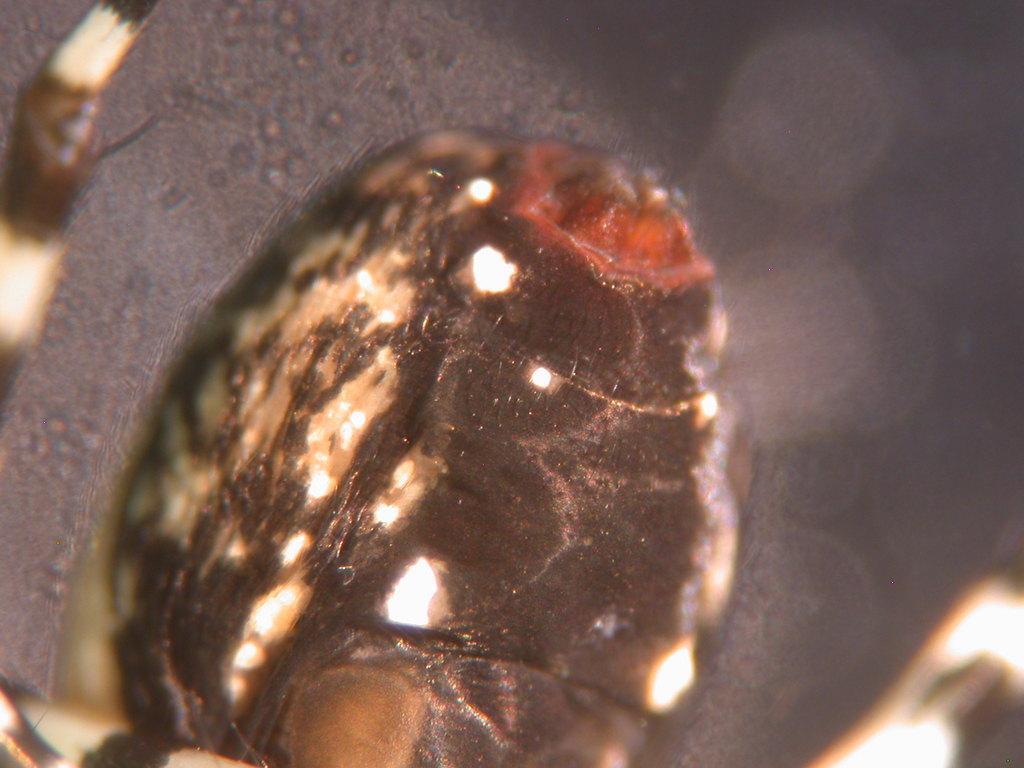What type of creature is present in the image? There is an insect in the image. What type of magic is the insect performing in the image? There is no magic present in the image; it is a simple image of an insect. 